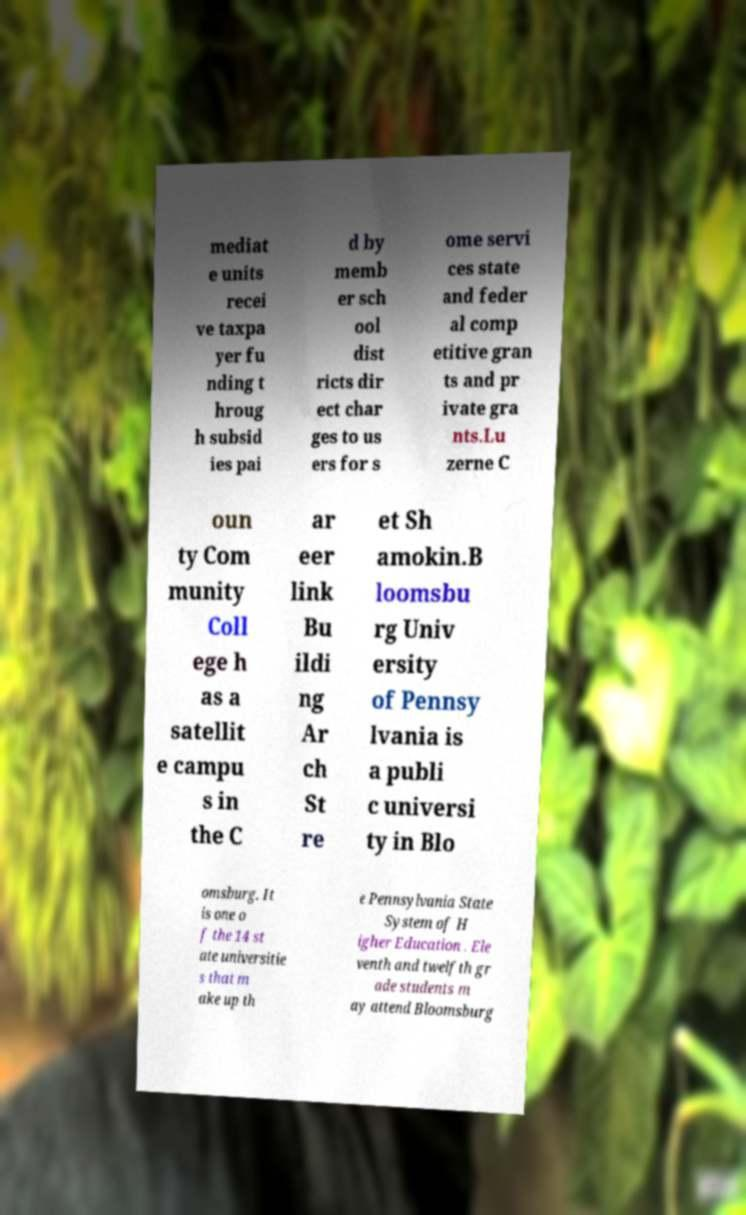For documentation purposes, I need the text within this image transcribed. Could you provide that? mediat e units recei ve taxpa yer fu nding t hroug h subsid ies pai d by memb er sch ool dist ricts dir ect char ges to us ers for s ome servi ces state and feder al comp etitive gran ts and pr ivate gra nts.Lu zerne C oun ty Com munity Coll ege h as a satellit e campu s in the C ar eer link Bu ildi ng Ar ch St re et Sh amokin.B loomsbu rg Univ ersity of Pennsy lvania is a publi c universi ty in Blo omsburg. It is one o f the 14 st ate universitie s that m ake up th e Pennsylvania State System of H igher Education . Ele venth and twelfth gr ade students m ay attend Bloomsburg 